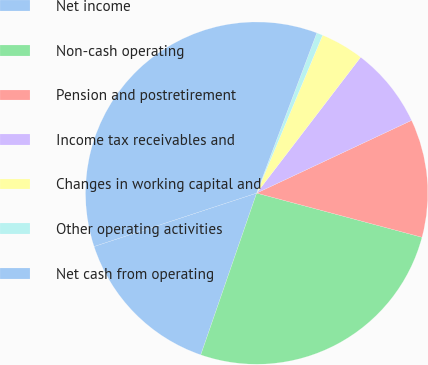Convert chart. <chart><loc_0><loc_0><loc_500><loc_500><pie_chart><fcel>Net income<fcel>Non-cash operating<fcel>Pension and postretirement<fcel>Income tax receivables and<fcel>Changes in working capital and<fcel>Other operating activities<fcel>Net cash from operating<nl><fcel>14.66%<fcel>26.14%<fcel>11.14%<fcel>7.62%<fcel>4.1%<fcel>0.58%<fcel>35.77%<nl></chart> 